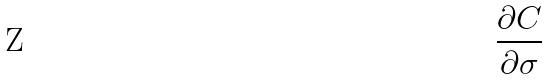Convert formula to latex. <formula><loc_0><loc_0><loc_500><loc_500>\frac { \partial C } { \partial \sigma }</formula> 